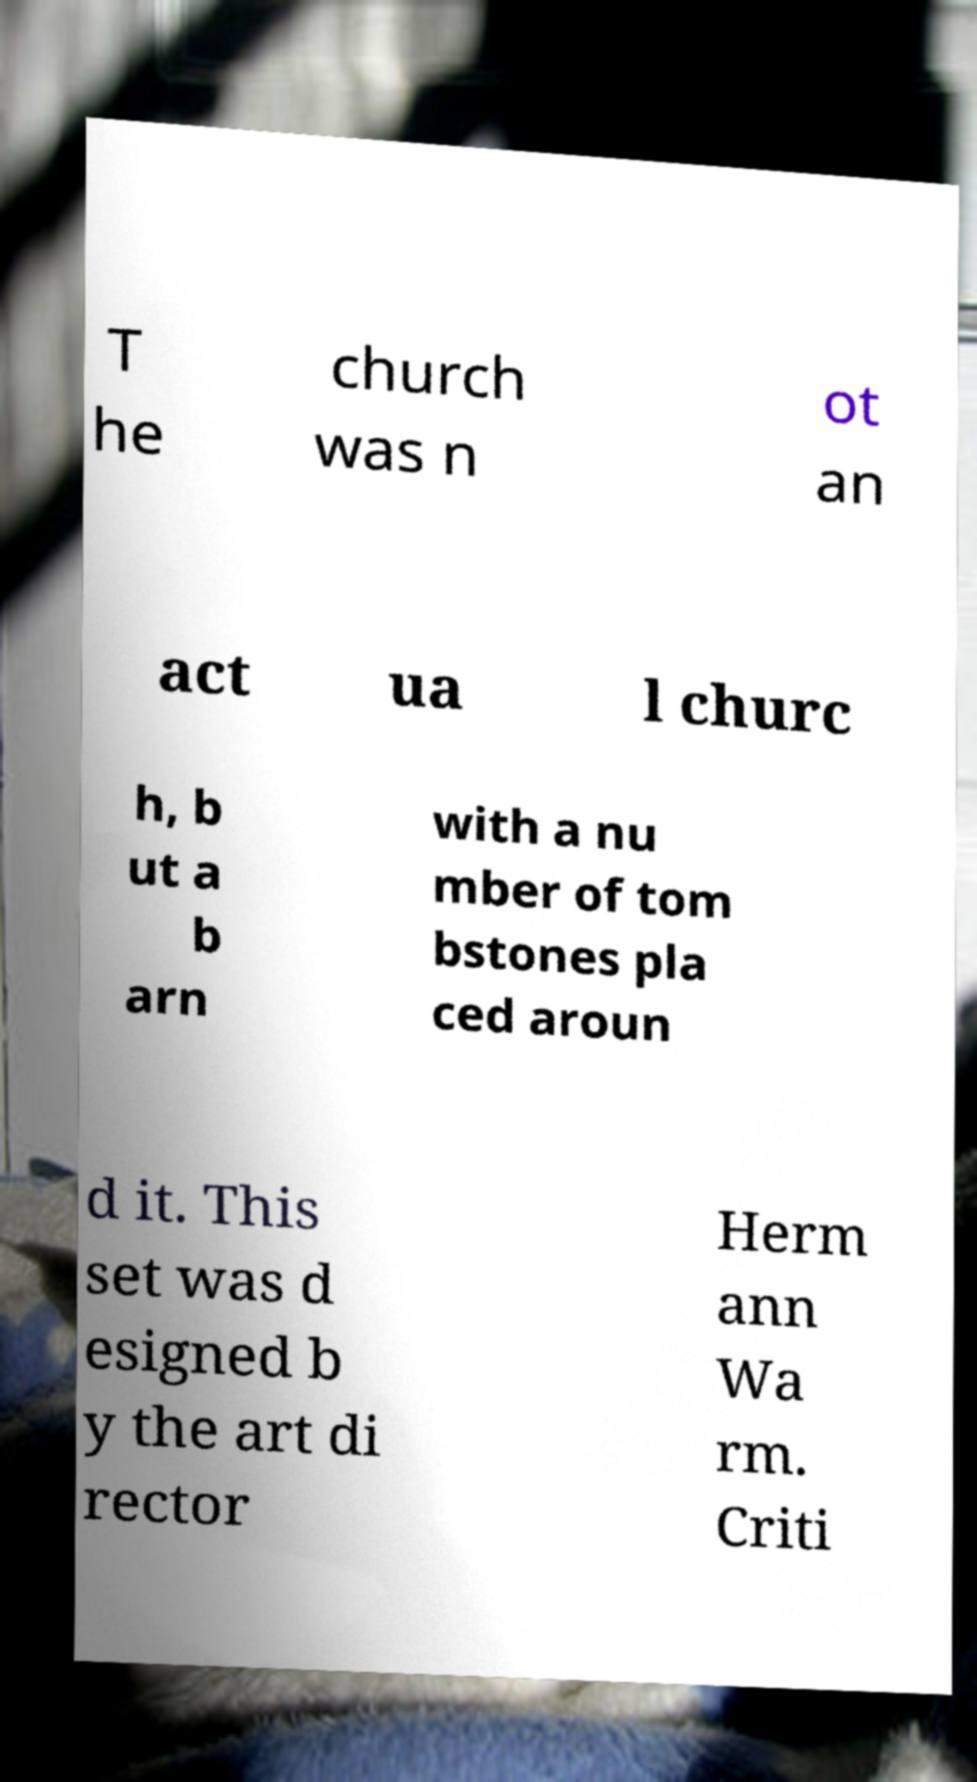I need the written content from this picture converted into text. Can you do that? T he church was n ot an act ua l churc h, b ut a b arn with a nu mber of tom bstones pla ced aroun d it. This set was d esigned b y the art di rector Herm ann Wa rm. Criti 